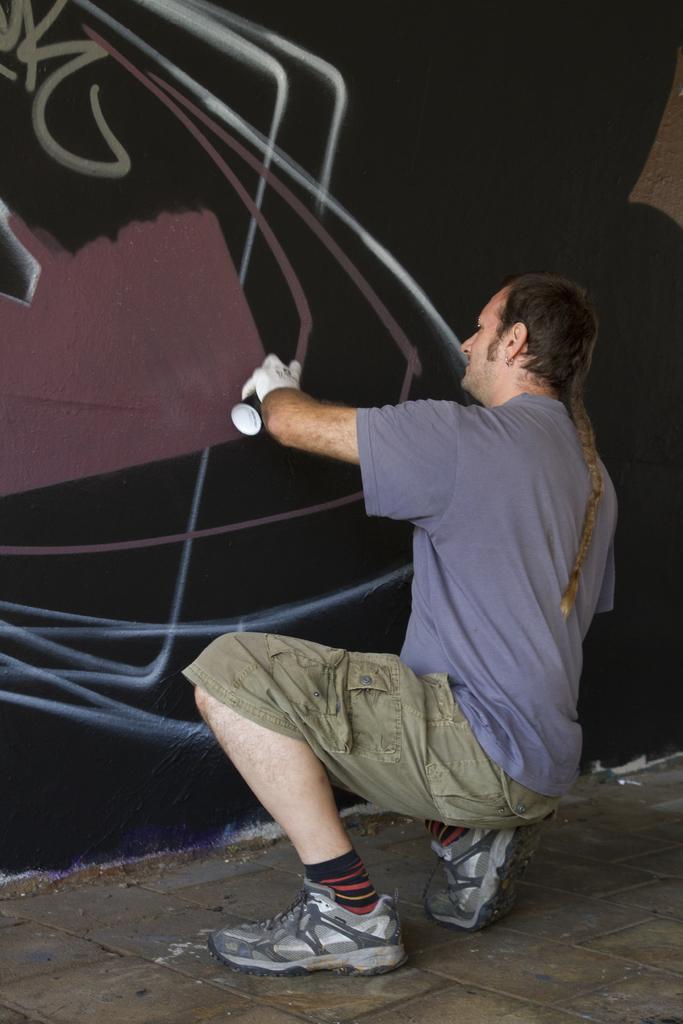Please provide a concise description of this image. In this image we can see a man in crouch position on the floor and he is holding a spray bottle in his hand and there are drawings on the wall. 